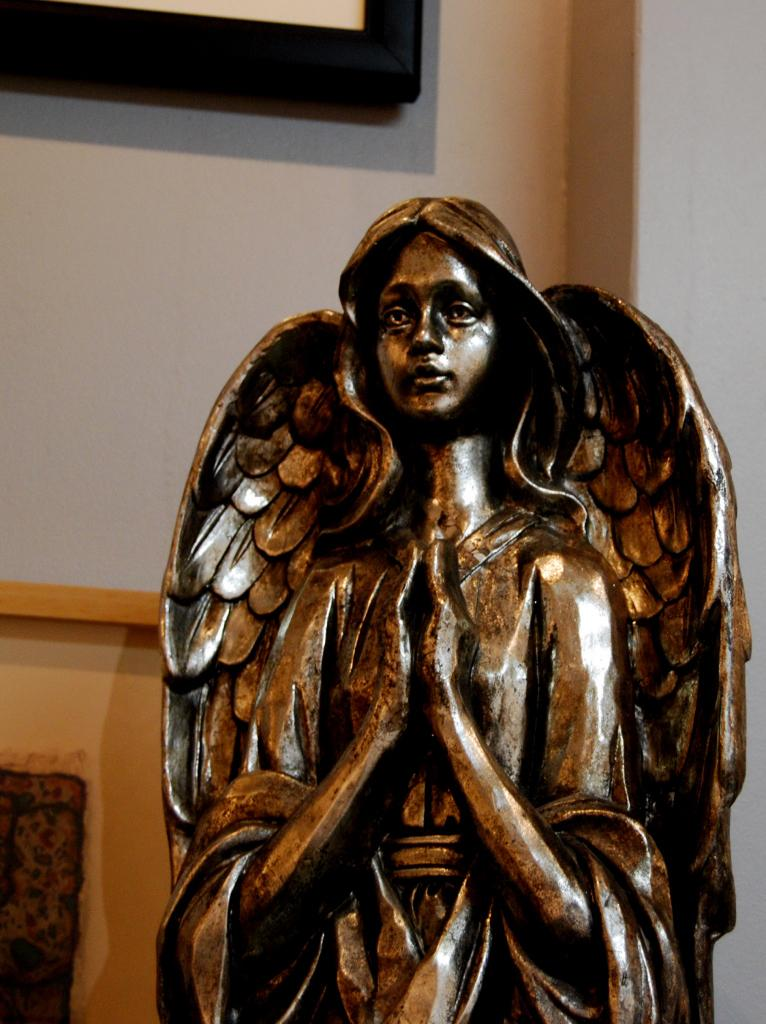What is the main subject of the image? There is a depiction of a woman with wings in the image. What can be seen in the background of the image? There is a wall in the background of the image. Is there any indication of how the image is displayed? Yes, there is a frame in the image. What grade did the woman with wings receive on her recent test? There is no information about a test or a grade in the image, as it features a depiction of a woman with wings and a wall in the background. 